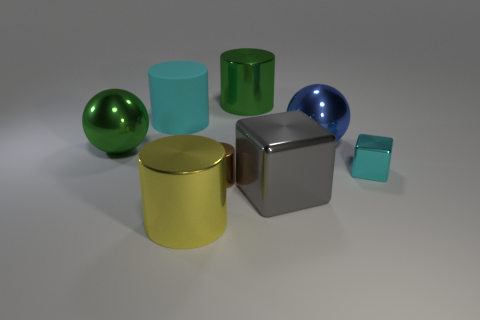What would happen to the shadows if we were to turn on a second light source to the left? Adding a second light source to the left would create additional shadows on the opposite side of the objects, making the overall shadow pattern more complex. The shadows would be less defined and softer, with the direction and intensity depending on the strength of the second light source. Could you explain how this would affect the appearance of the shiny and matte objects differently? Certainly! The shiny objects would reflect more light and likely show highlights from the additional light source. Their reflective quality would cause them to have brighter spots and possibly more defined reflections. The matte objects, on the other hand, wouldn't reflect the light as much, but their shadows would become less distinct with softer edges due to the presence of another light diminishing the contrast. 